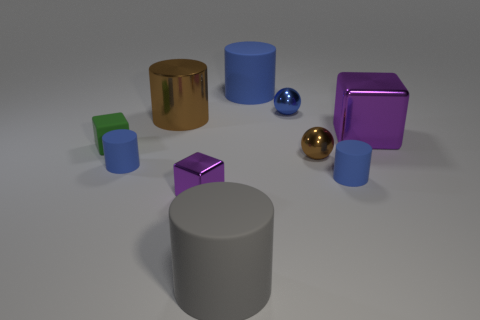Are there an equal number of tiny brown balls that are behind the brown metallic ball and rubber cylinders?
Ensure brevity in your answer.  No. What number of things are either large purple metal things or blocks that are in front of the small rubber cube?
Your answer should be compact. 2. Is there another gray thing that has the same shape as the gray thing?
Your response must be concise. No. Are there the same number of large things that are in front of the green matte cube and matte things to the right of the small purple block?
Provide a succinct answer. No. How many yellow objects are tiny things or rubber cylinders?
Keep it short and to the point. 0. What number of blue metal objects are the same size as the green matte block?
Keep it short and to the point. 1. What is the color of the object that is behind the small brown shiny ball and right of the tiny blue metallic sphere?
Ensure brevity in your answer.  Purple. Are there more tiny cubes that are to the left of the tiny purple block than big red balls?
Provide a short and direct response. Yes. Are there any small metal cylinders?
Keep it short and to the point. No. Is the large block the same color as the tiny matte block?
Make the answer very short. No. 